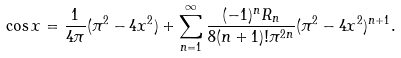<formula> <loc_0><loc_0><loc_500><loc_500>\cos x = \frac { 1 } { 4 \pi } ( \pi ^ { 2 } - 4 x ^ { 2 } ) + \sum _ { n = 1 } ^ { \infty } \frac { ( - 1 ) ^ { n } R _ { n } } { 8 ( n + 1 ) ! \pi ^ { 2 n } } ( \pi ^ { 2 } - 4 x ^ { 2 } ) ^ { n + 1 } .</formula> 